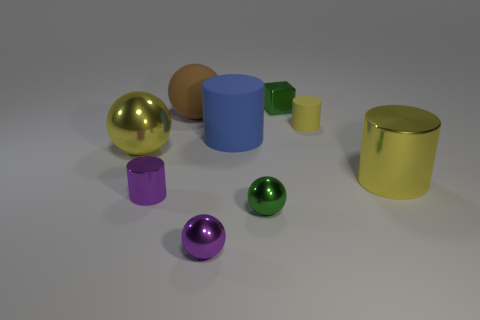What number of big rubber objects have the same shape as the small rubber thing?
Your response must be concise. 1. There is a tiny green thing that is the same material as the small cube; what shape is it?
Your answer should be compact. Sphere. What shape is the metal object behind the large cylinder behind the large cylinder that is in front of the blue rubber thing?
Make the answer very short. Cube. Are there more brown things than matte cylinders?
Your answer should be compact. No. What is the material of the purple object that is the same shape as the small yellow rubber thing?
Provide a short and direct response. Metal. Do the tiny green cube and the blue cylinder have the same material?
Your answer should be very brief. No. Are there more tiny purple metallic spheres that are on the right side of the big blue rubber cylinder than large brown rubber objects?
Your response must be concise. No. There is a small sphere that is to the right of the metallic thing in front of the green metal thing that is in front of the metallic cube; what is its material?
Provide a short and direct response. Metal. How many things are either brown matte things or yellow cylinders that are to the right of the tiny yellow matte cylinder?
Give a very brief answer. 2. There is a shiny ball that is left of the tiny purple metallic cylinder; is its color the same as the large rubber cylinder?
Your answer should be very brief. No. 